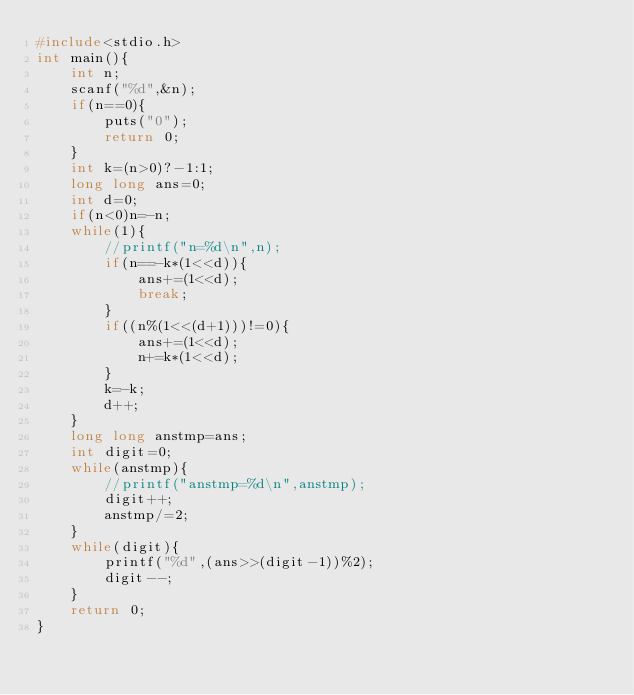<code> <loc_0><loc_0><loc_500><loc_500><_C_>#include<stdio.h>
int main(){
    int n;
    scanf("%d",&n);
    if(n==0){
        puts("0");
        return 0;
    }
    int k=(n>0)?-1:1;
    long long ans=0;
    int d=0;
    if(n<0)n=-n;
    while(1){
        //printf("n=%d\n",n);
        if(n==-k*(1<<d)){
            ans+=(1<<d);
            break;
        }
        if((n%(1<<(d+1)))!=0){
            ans+=(1<<d);
            n+=k*(1<<d);
        }
        k=-k;
        d++;
    }
    long long anstmp=ans;
    int digit=0;
    while(anstmp){
        //printf("anstmp=%d\n",anstmp);
        digit++;
        anstmp/=2;
    }
    while(digit){
        printf("%d",(ans>>(digit-1))%2);
        digit--;
    }
    return 0;
}
</code> 